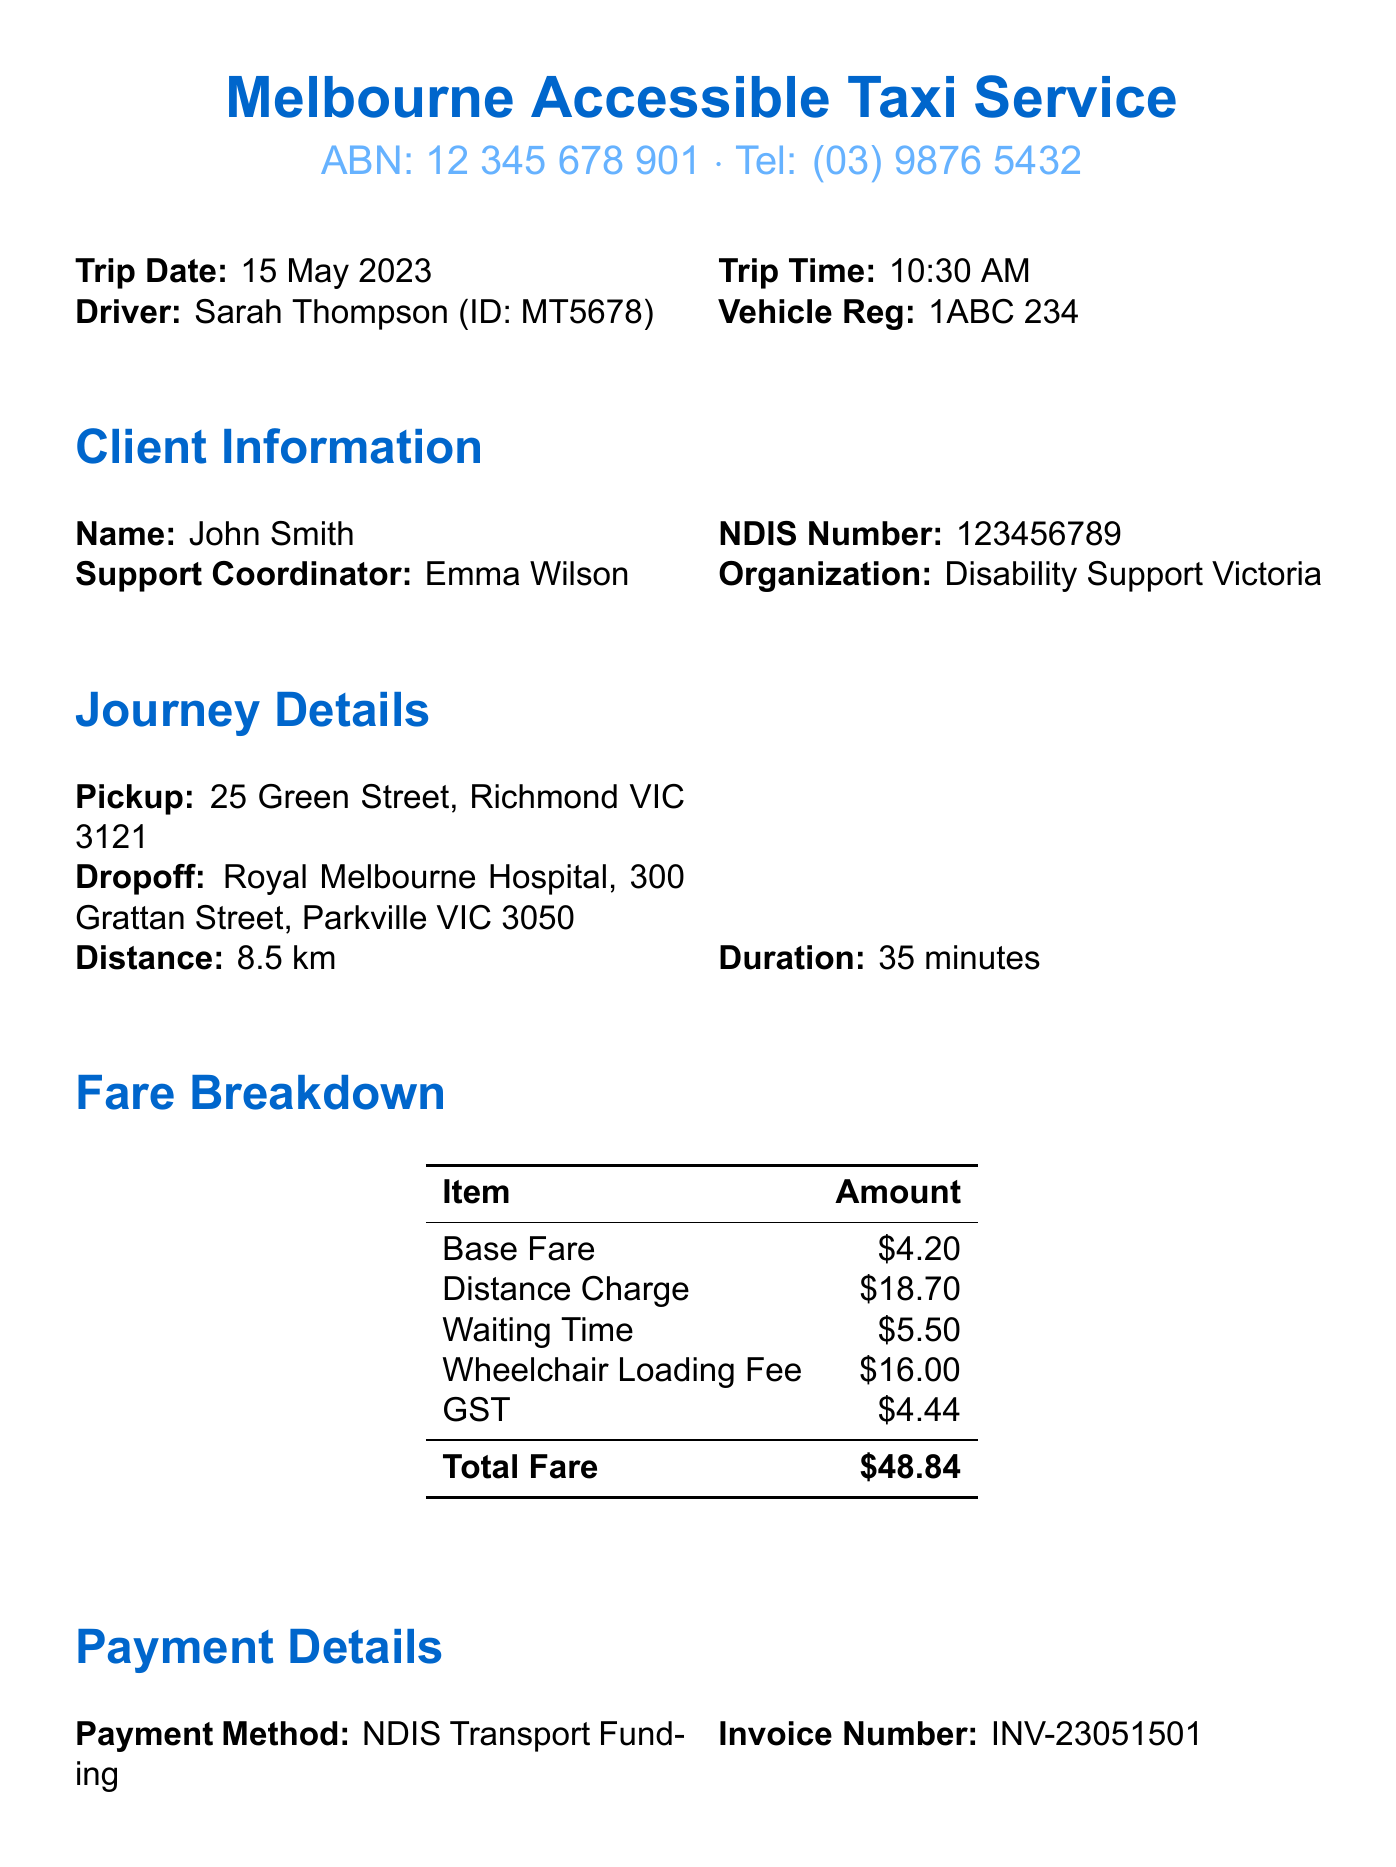what is the total fare? The total fare is the amount listed at the end of the fare breakdown section, which includes all charges.
Answer: $48.84 who was the driver for this trip? The driver's name is stated in the trip details section of the document.
Answer: Sarah Thompson what is the pickup location? The pickup location is specified in the journey details section of the document.
Answer: 25 Green Street, Richmond VIC 3121 what was the distance travelled? The distance travelled is mentioned in the journey information section, indicating how far the vehicle went.
Answer: 8.5 km what is the payment method used? The payment method is listed under the payment details section of the document.
Answer: NDIS Transport Funding what type of vehicle was used for the trip? The vehicle type is specified in the additional information section, depicting the kind of vehicle used for transporting the client.
Answer: Wheelchair Accessible Vehicle (WAV) how long did the trip take? The trip duration is provided in the journey information section of the document, indicating the time taken for the trip.
Answer: 35 minutes what is the cancellation policy? The cancellation policy outlines the conditions for cancelling the trip, found in the policy information section of the document.
Answer: Cancellations with less than 2 hours notice may incur a fee what is the invoice number? The invoice number is mentioned in the payment details section of the document, identifying the specific transaction.
Answer: INV-23051501 